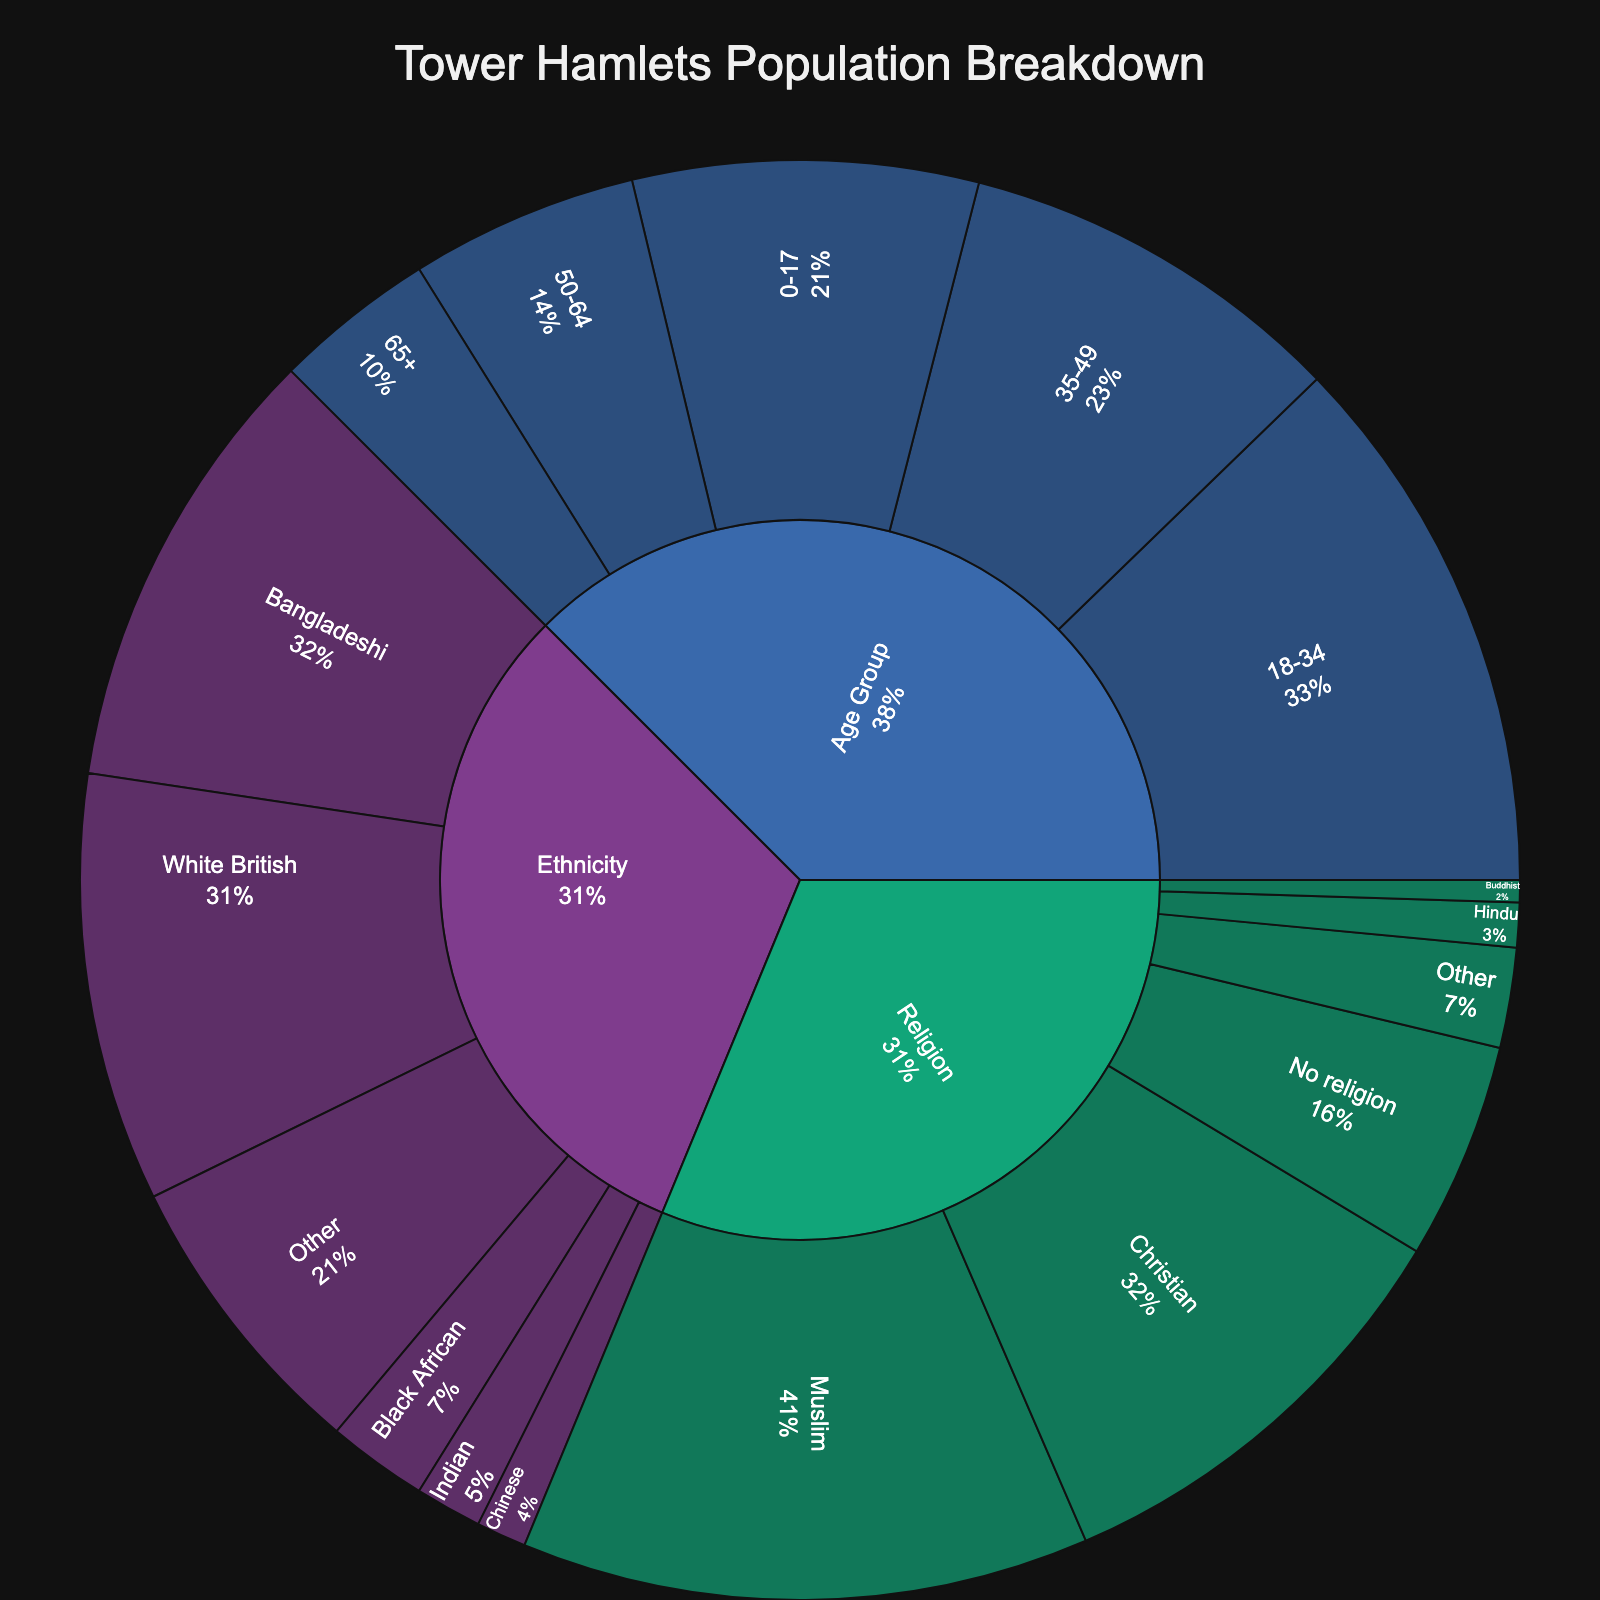what is the most common ethnicity in Tower Hamlets? By looking at the sunburst plot under the "Ethnicity" category, the largest segment corresponds to the "Bangladeshi" subcategory/population.
Answer: Bangladeshi How many people are there in the 18-34 age group? Navigate the sunburst plot to the "Age Group" category and find the segment labeled "18-34". The value associated with this segment is the count of people.
Answer: 98,000 Which religion has the second smallest population in Tower Hamlets? Under the "Religion" category in the sunburst plot, identify the segments and compare their values. The segment with the second smallest value follows "Buddhist" with 4,000, and the next in line is "Hindu" with 8,000.
Answer: Hindu What is the combined population of residents aged 50+ in Tower Hamlets? Look at the "Age Group" category in the sunburst plot and identify the segments "50-64" and "65+". Add these values together: 41,000 + 29,000 = 70,000.
Answer: 70,000 How does the population of Muslims compare to that of Christians? Under the "Religion" category, observe the segments labeled "Muslim" and "Christian". Muslims have a value of 102,000 and Christians have a value of 79,000. To compare, Muslims have a greater population than Christians.
Answer: Muslims have a greater population What proportion of the total population does the ‘Other’ ethnicity category represent? In the "Ethnicity" category, find the "Other" segment with a value of 53,000. Calculate the total population across all segments and then find the proportion for "Other": (53,000 / (77,000 + 81,000 + 18,000 + 12,000 + 9,000 + 53,000)) ≈ 0.163 or 16.3%.
Answer: 16.3% How does the population size of the 0-17 and 35-49 age groups together compare with the Bangladeshi ethnicity population? Combine the counts of the "0-17" and "35-49" age groups: 62,000 + 70,000 = 132,000. Then, compare this with the Bangladeshi ethnicity population of 81,000. 132,000 is larger than 81,000.
Answer: Combined age groups are larger What's the average population size across all religious categories? Sum all values in the "Religion" category: 102,000 (Muslim) + 79,000 (Christian) + 39,000 (No religion) + 8,000 (Hindu) + 4,000 (Buddhist) + 18,000 (Other) = 250,000. There are six categories, so the average is: 250,000 / 6 ≈ 41,667.
Answer: 41,667 Which group has a larger population: White British or the 35-49 age group? Examine the values in the sunburst plot for "White British" under "Ethnicity" (77,000) and "35-49" under "Age Group" (70,000). The White British population is larger.
Answer: White British How many total unique subcategories are represented in the sunburst plot? Count all unique subcategories under "Ethnicity", "Religion", and "Age Group". There are 6 (Ethnicity) + 6 (Religion) + 5 (Age Group) = 17.
Answer: 17 